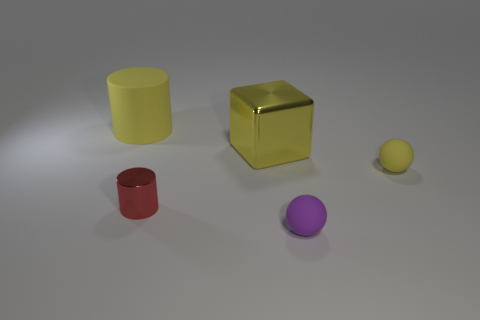There is a big cylinder that is the same color as the big block; what material is it? The material of the big cylinder that matches the color of the large block in the image cannot be determined with certainty just from visual inspection, as many materials can be painted or treated to achieve a similar appearance. However, assuming they are the same material due to their color similarity, they could potentially be made of plastic, a common material for uniformly colored objects in a still life composition such as this. 